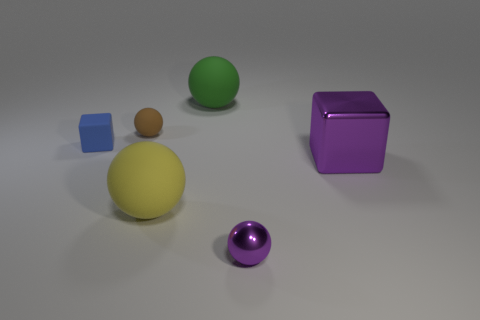There is a big ball that is behind the big thing on the left side of the green rubber thing; how many green matte spheres are to the right of it?
Your answer should be very brief. 0. There is a big purple shiny cube; are there any large purple metal things to the left of it?
Offer a very short reply. No. How many other things are there of the same size as the yellow ball?
Keep it short and to the point. 2. There is a large object that is in front of the small brown matte ball and left of the purple cube; what material is it?
Your answer should be compact. Rubber. There is a large purple metal object behind the small shiny thing; is it the same shape as the large rubber object that is behind the blue cube?
Make the answer very short. No. Is there anything else that has the same material as the tiny blue cube?
Give a very brief answer. Yes. The metallic thing that is to the left of the block right of the small sphere on the left side of the small purple metal object is what shape?
Provide a short and direct response. Sphere. What number of other things are there of the same shape as the small purple thing?
Provide a succinct answer. 3. There is a rubber sphere that is the same size as the green matte object; what color is it?
Make the answer very short. Yellow. How many cylinders are brown things or small matte things?
Ensure brevity in your answer.  0. 